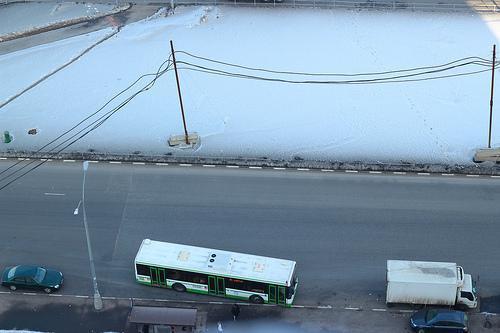How many vehicles can be seen?
Give a very brief answer. 4. 